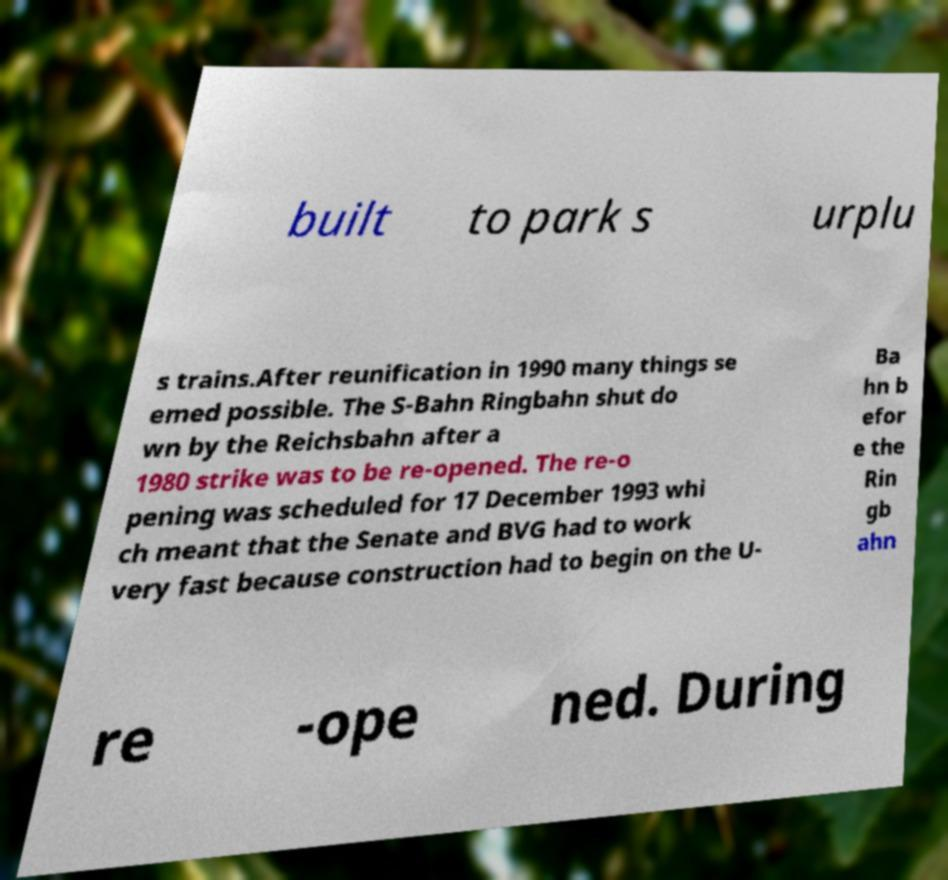I need the written content from this picture converted into text. Can you do that? built to park s urplu s trains.After reunification in 1990 many things se emed possible. The S-Bahn Ringbahn shut do wn by the Reichsbahn after a 1980 strike was to be re-opened. The re-o pening was scheduled for 17 December 1993 whi ch meant that the Senate and BVG had to work very fast because construction had to begin on the U- Ba hn b efor e the Rin gb ahn re -ope ned. During 